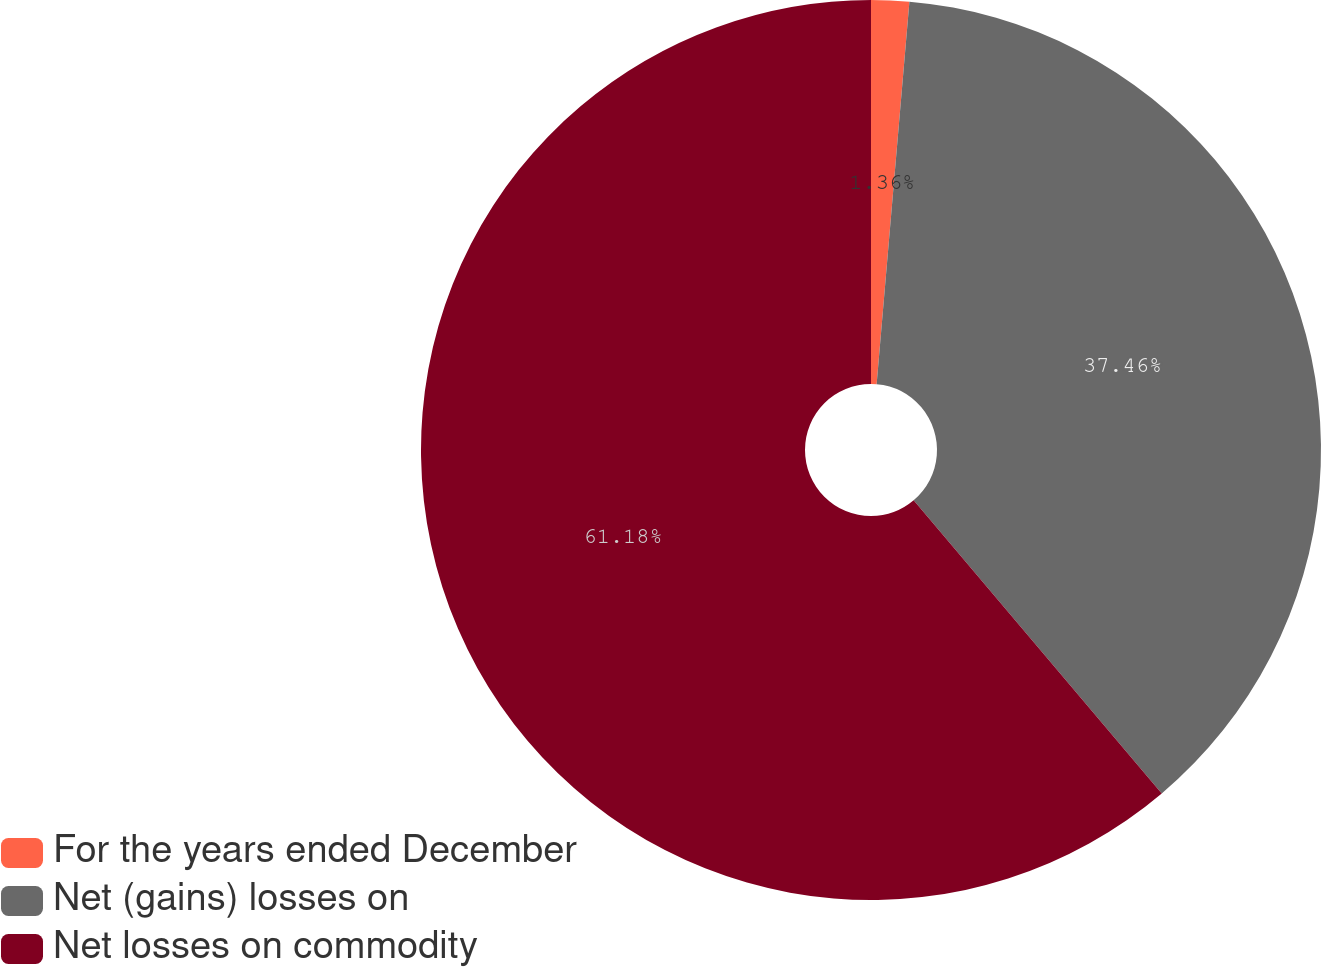Convert chart to OTSL. <chart><loc_0><loc_0><loc_500><loc_500><pie_chart><fcel>For the years ended December<fcel>Net (gains) losses on<fcel>Net losses on commodity<nl><fcel>1.36%<fcel>37.46%<fcel>61.18%<nl></chart> 